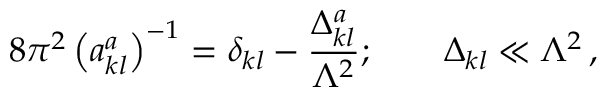<formula> <loc_0><loc_0><loc_500><loc_500>8 \pi ^ { 2 } \left ( a _ { k l } ^ { a } \right ) ^ { - 1 } = \delta _ { k l } - \frac { \Delta _ { k l } ^ { a } } { \Lambda ^ { 2 } } ; \quad \Delta _ { k l } \ll \Lambda ^ { 2 } \, ,</formula> 